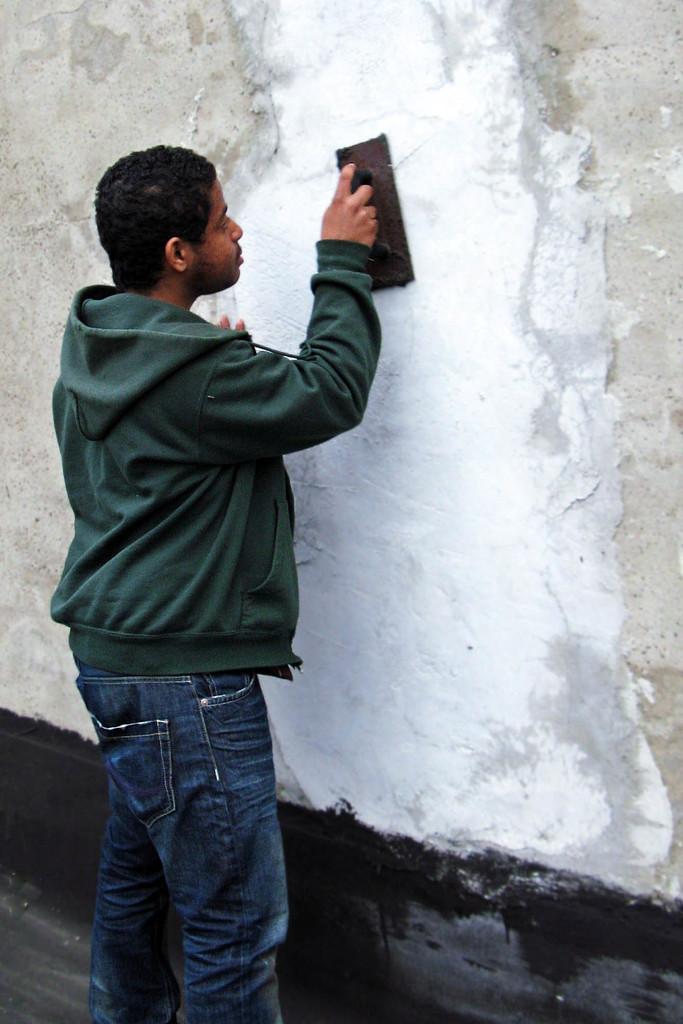In one or two sentences, can you explain what this image depicts? Here I can see a man wearing a jacket, holding an object in the hand and facing towards the wall. It seems like he is painting the wall. 